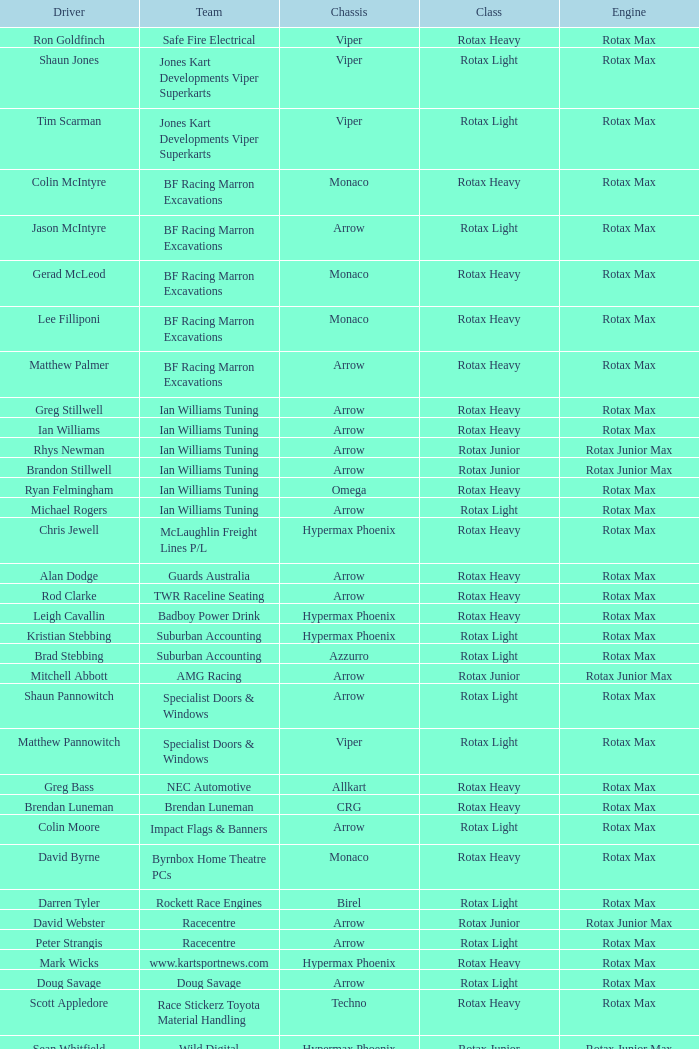Which team does Colin Moore drive for? Impact Flags & Banners. 